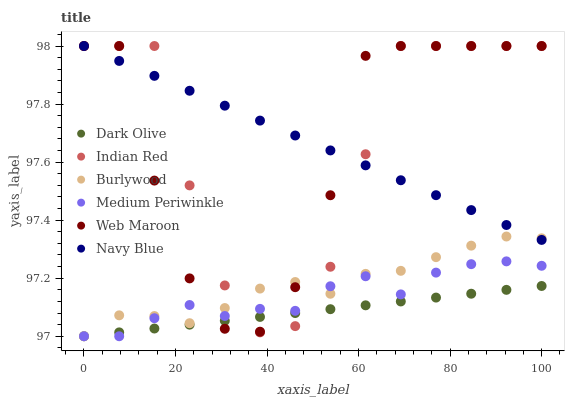Does Dark Olive have the minimum area under the curve?
Answer yes or no. Yes. Does Navy Blue have the maximum area under the curve?
Answer yes or no. Yes. Does Medium Periwinkle have the minimum area under the curve?
Answer yes or no. No. Does Medium Periwinkle have the maximum area under the curve?
Answer yes or no. No. Is Dark Olive the smoothest?
Answer yes or no. Yes. Is Web Maroon the roughest?
Answer yes or no. Yes. Is Medium Periwinkle the smoothest?
Answer yes or no. No. Is Medium Periwinkle the roughest?
Answer yes or no. No. Does Burlywood have the lowest value?
Answer yes or no. Yes. Does Web Maroon have the lowest value?
Answer yes or no. No. Does Navy Blue have the highest value?
Answer yes or no. Yes. Does Medium Periwinkle have the highest value?
Answer yes or no. No. Is Dark Olive less than Navy Blue?
Answer yes or no. Yes. Is Navy Blue greater than Dark Olive?
Answer yes or no. Yes. Does Burlywood intersect Navy Blue?
Answer yes or no. Yes. Is Burlywood less than Navy Blue?
Answer yes or no. No. Is Burlywood greater than Navy Blue?
Answer yes or no. No. Does Dark Olive intersect Navy Blue?
Answer yes or no. No. 